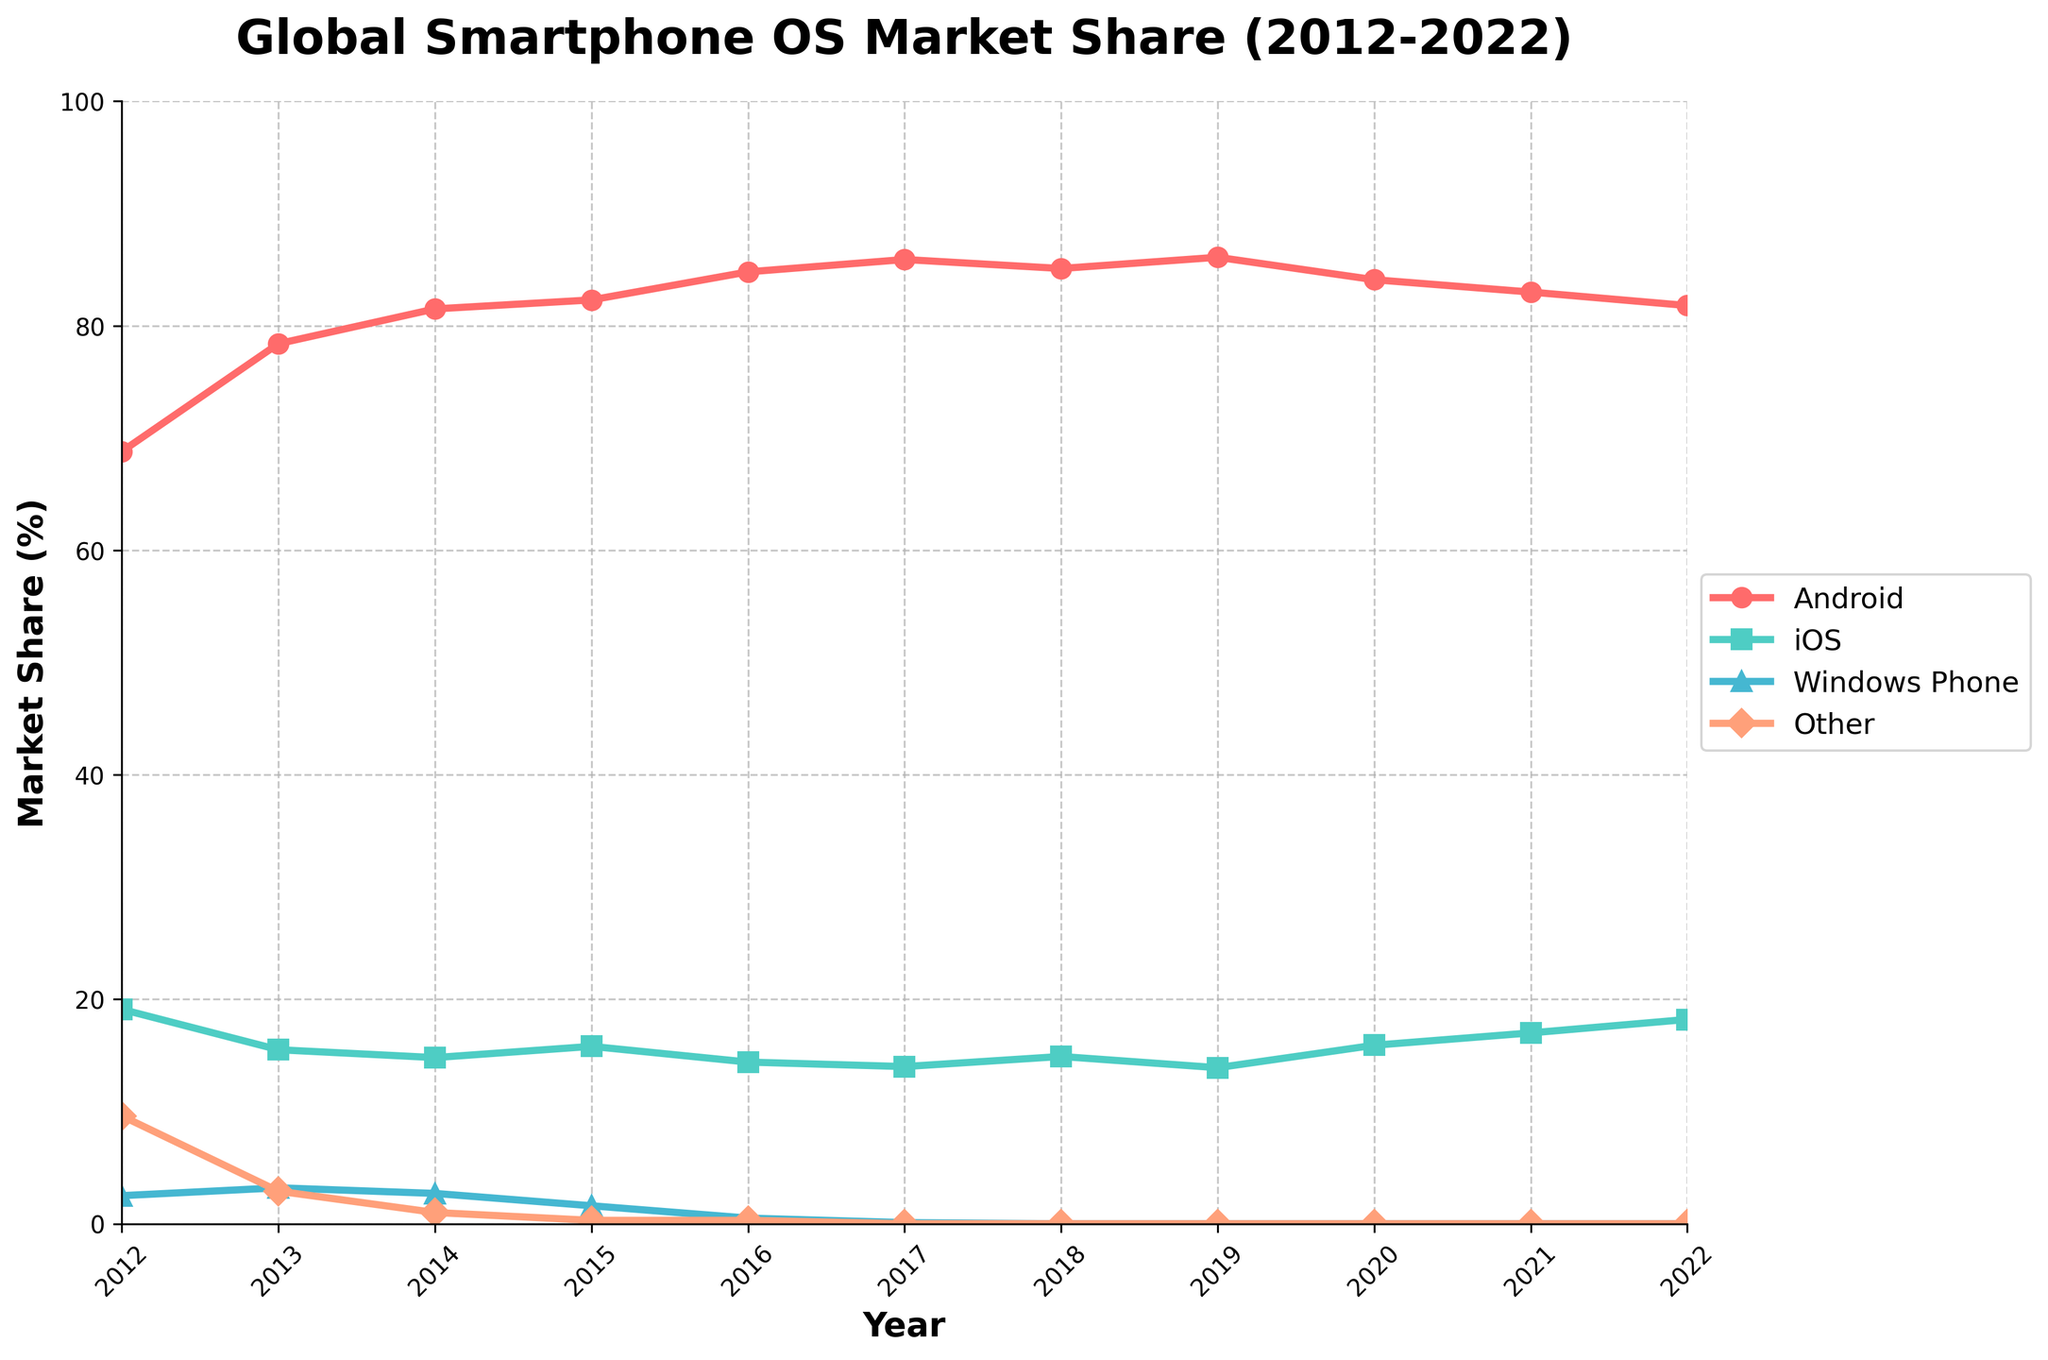What is the overall trend for Android's market share from 2012 to 2022? To determine the overall trend, we observe Android's market share data points year by year. From 2012 to 2022, the percentage generally increases, peaking at 86.1% in 2019, and then slightly decreases to 81.8% in 2022. This indicates an overall upward trend with minor fluctuations.
Answer: Upward trend How does iOS's market share in 2022 compare to its share in 2012? To compare the two values, look at the percentages for iOS in both years. In 2012, the market share was 19.1%, and in 2022, it was 18.2%. Therefore, it's slightly lower in 2022 than in 2012.
Answer: Lower in 2022 Which operating system had the largest market share at its peak, and what was the value? Observe the highest data values for each OS line. Android has the largest peak market share value at 86.1% in 2019.
Answer: Android, 86.1% What year did Windows Phone's market share drop to 0%? Track the Windows Phone line and identify the first year it hits 0%. The market share drops to 0% in 2018.
Answer: 2018 Is there any period where the market share of 'Other' OS was greater than iOS? Compare the 'Other' line and the iOS line on the plot. In 2012, 'Other' had a market share of 9.6%, which is less than iOS's 19.1%. There is no period where 'Other' exceeds iOS.
Answer: No Between 2014 and 2020, which OS shows more stability in market share, Android or iOS? Stability can be measured by small fluctuations. Observe the changes from 2014 to 2020 for both OS. Android fluctuates between 81.5% and 86.1%, whereas iOS ranges from 14.8% to 15.9%. iOS shows less fluctuation.
Answer: iOS Calculate the average market share for 'Other' OS from 2012 to 2022. Add the market share values of 'Other' OS across the years and divide by the number of years: (9.6 + 2.9 + 1.0 + 0.3 + 0.3 + 0.0 + 0.0 + 0.0 + 0.0 + 0.0 + 0.0) / 11. The sum is 14.1, and the average is 14.1 / 11 ≈ 1.3%.
Answer: 1.3% What is the percentage change in market share for Android between 2016 and 2019? Calculate the difference in Android's market share between these years and then find the percentage relative to 2016: (86.1 - 84.8) / 84.8 * 100 = 1.53%.
Answer: 1.53% Which year experienced the sharpest decline in Android's market share, and what was the difference between the consecutive years? Look for the largest drop between consecutive years for Android. The sharpest decline is between 2019 and 2020, where the market share drops from 86.1% to 84.1%, a difference of 2.0%.
Answer: 2020, 2.0% In which year did iOS see its highest market share, and what was the percentage? The iOS line's highest point occurs in 2012 with a percentage of 19.1%.
Answer: 2012, 19.1% 